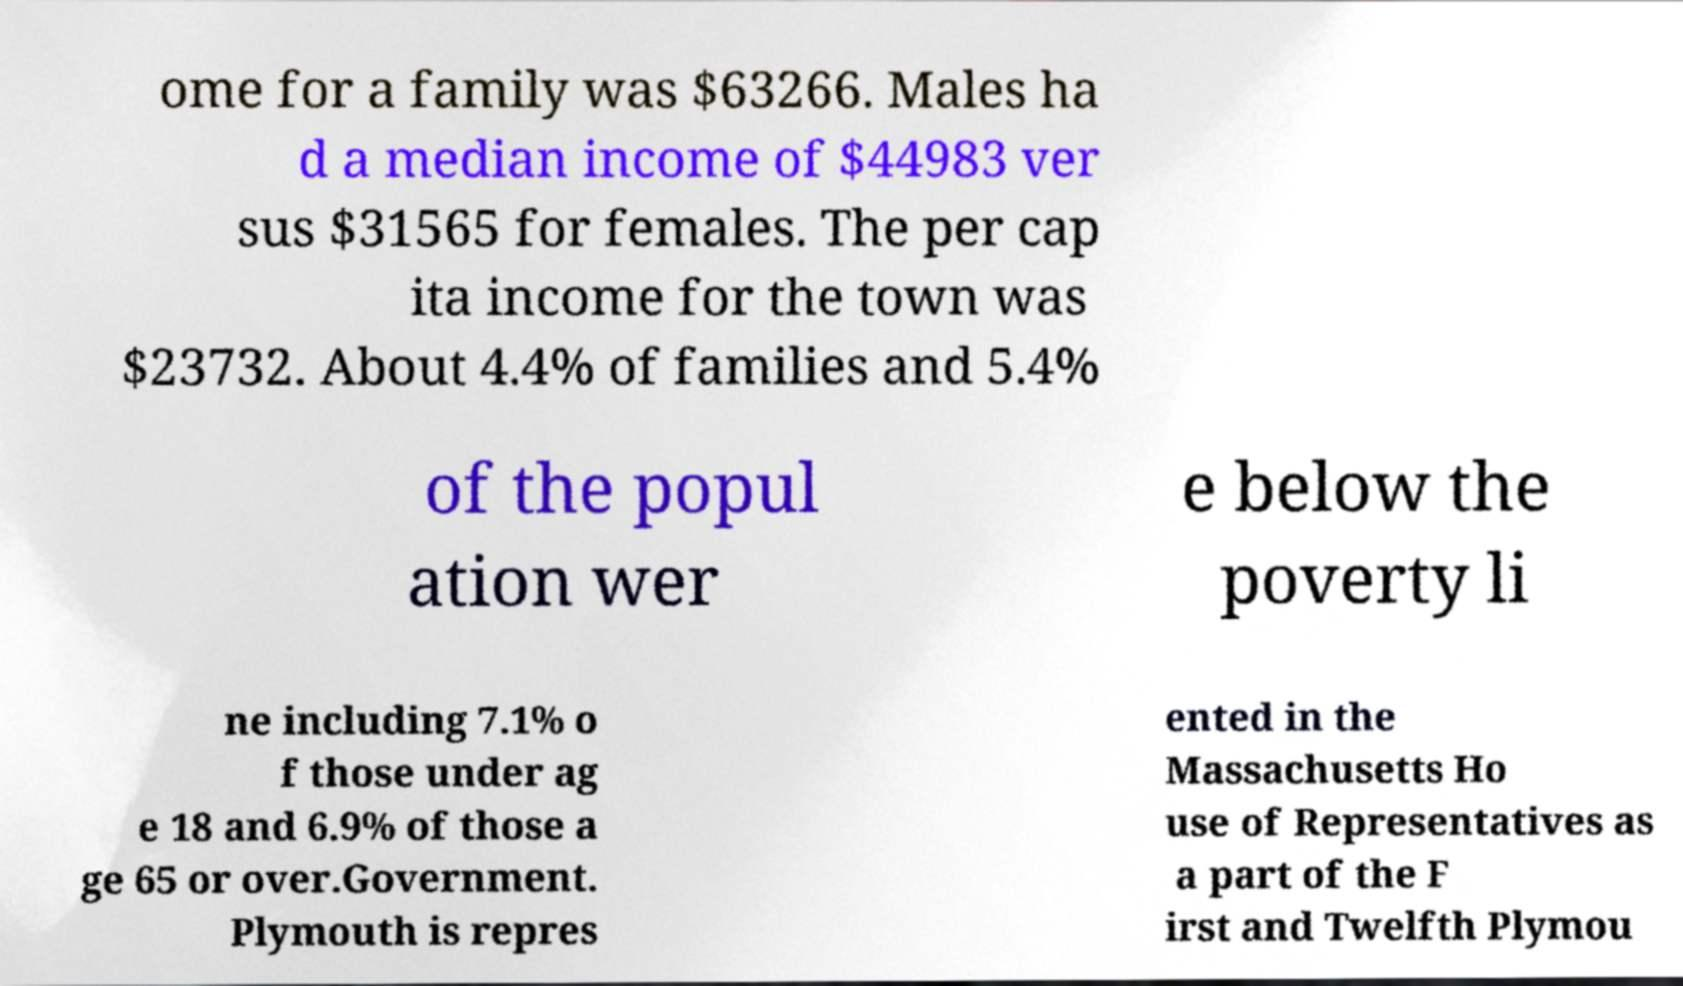What messages or text are displayed in this image? I need them in a readable, typed format. ome for a family was $63266. Males ha d a median income of $44983 ver sus $31565 for females. The per cap ita income for the town was $23732. About 4.4% of families and 5.4% of the popul ation wer e below the poverty li ne including 7.1% o f those under ag e 18 and 6.9% of those a ge 65 or over.Government. Plymouth is repres ented in the Massachusetts Ho use of Representatives as a part of the F irst and Twelfth Plymou 